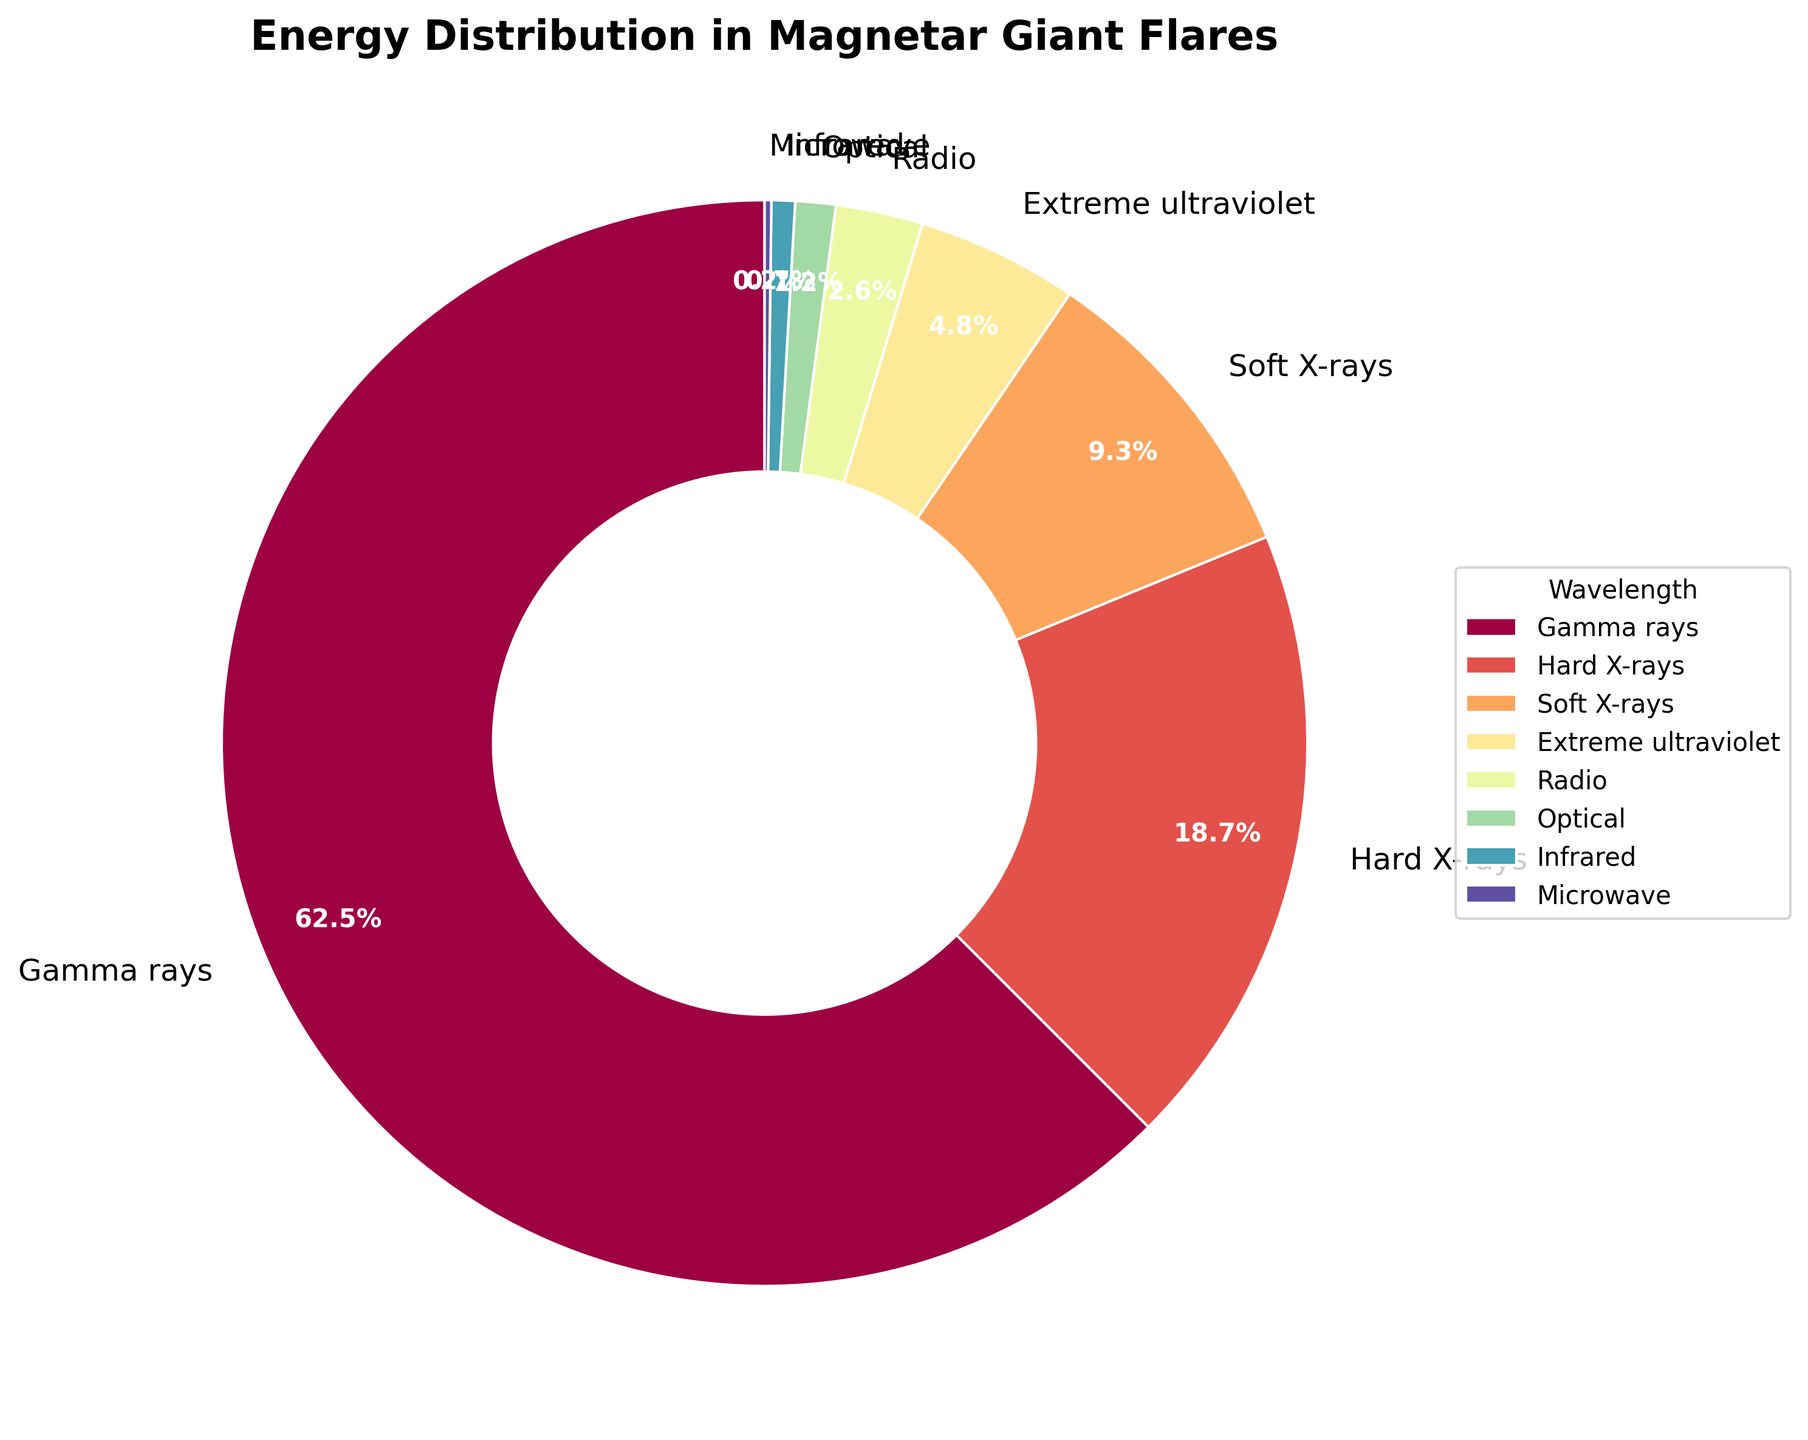Which wavelength contributes the most to the energy distribution? By examining the pie chart, the largest wedge represents the wavelength with the highest percentage. In this case, it's the segment labeled "Gamma rays" with 62.5%.
Answer: Gamma rays What is the combined energy percentage of Hard X-rays and Soft X-rays? To find the combined percentage, add the percentages for Hard X-rays (18.7%) and Soft X-rays (9.3%). So, 18.7% + 9.3% = 28%.
Answer: 28% Which wavelength contributes the least to the energy distribution? The smallest wedge in the pie chart represents the wavelength with the lowest percentage. This is the segment labeled "Microwave" with 0.2%.
Answer: Microwave How does the energy percentage of Optical compare to that of Infrared? By looking at the sizes and labels of the wedges for Optical and Infrared, Optical has 1.2% and Infrared has 0.7%. Comparing these, Optical (1.2%) is greater than Infrared (0.7%).
Answer: Optical is greater than Infrared What is the total percentage of energy distribution in wavelengths other than Gamma rays? To find this, subtract the percentage of Gamma rays (62.5%) from the total (100%). So, 100% - 62.5% = 37.5%.
Answer: 37.5% What are the top three contributors to the energy distribution? Examine the pie chart and identify the three largest wedges by percentage. The top three are Gamma rays (62.5%), Hard X-rays (18.7%), and Soft X-rays (9.3%).
Answer: Gamma rays, Hard X-rays, Soft X-rays What is the difference in the energy percentage between Hard X-rays and Extreme ultraviolet? Subtract the percentage of Extreme ultraviolet (4.8%) from Hard X-rays (18.7%). So, 18.7% - 4.8% = 13.9%.
Answer: 13.9% What percentage does the combined Infrared and Microwave contribute to the energy distribution? Add the percentages for Infrared (0.7%) and Microwave (0.2%). So, 0.7% + 0.2% = 0.9%.
Answer: 0.9% Which wavelength segment is the color at the start angle of the pie chart? The start angle of the pie chart is 90 degrees, and the segment starting from this angle is the first one listed. Referring to the chart, Gamma rays is the first segment, marked by this characteristic color.
Answer: Gamma rays 